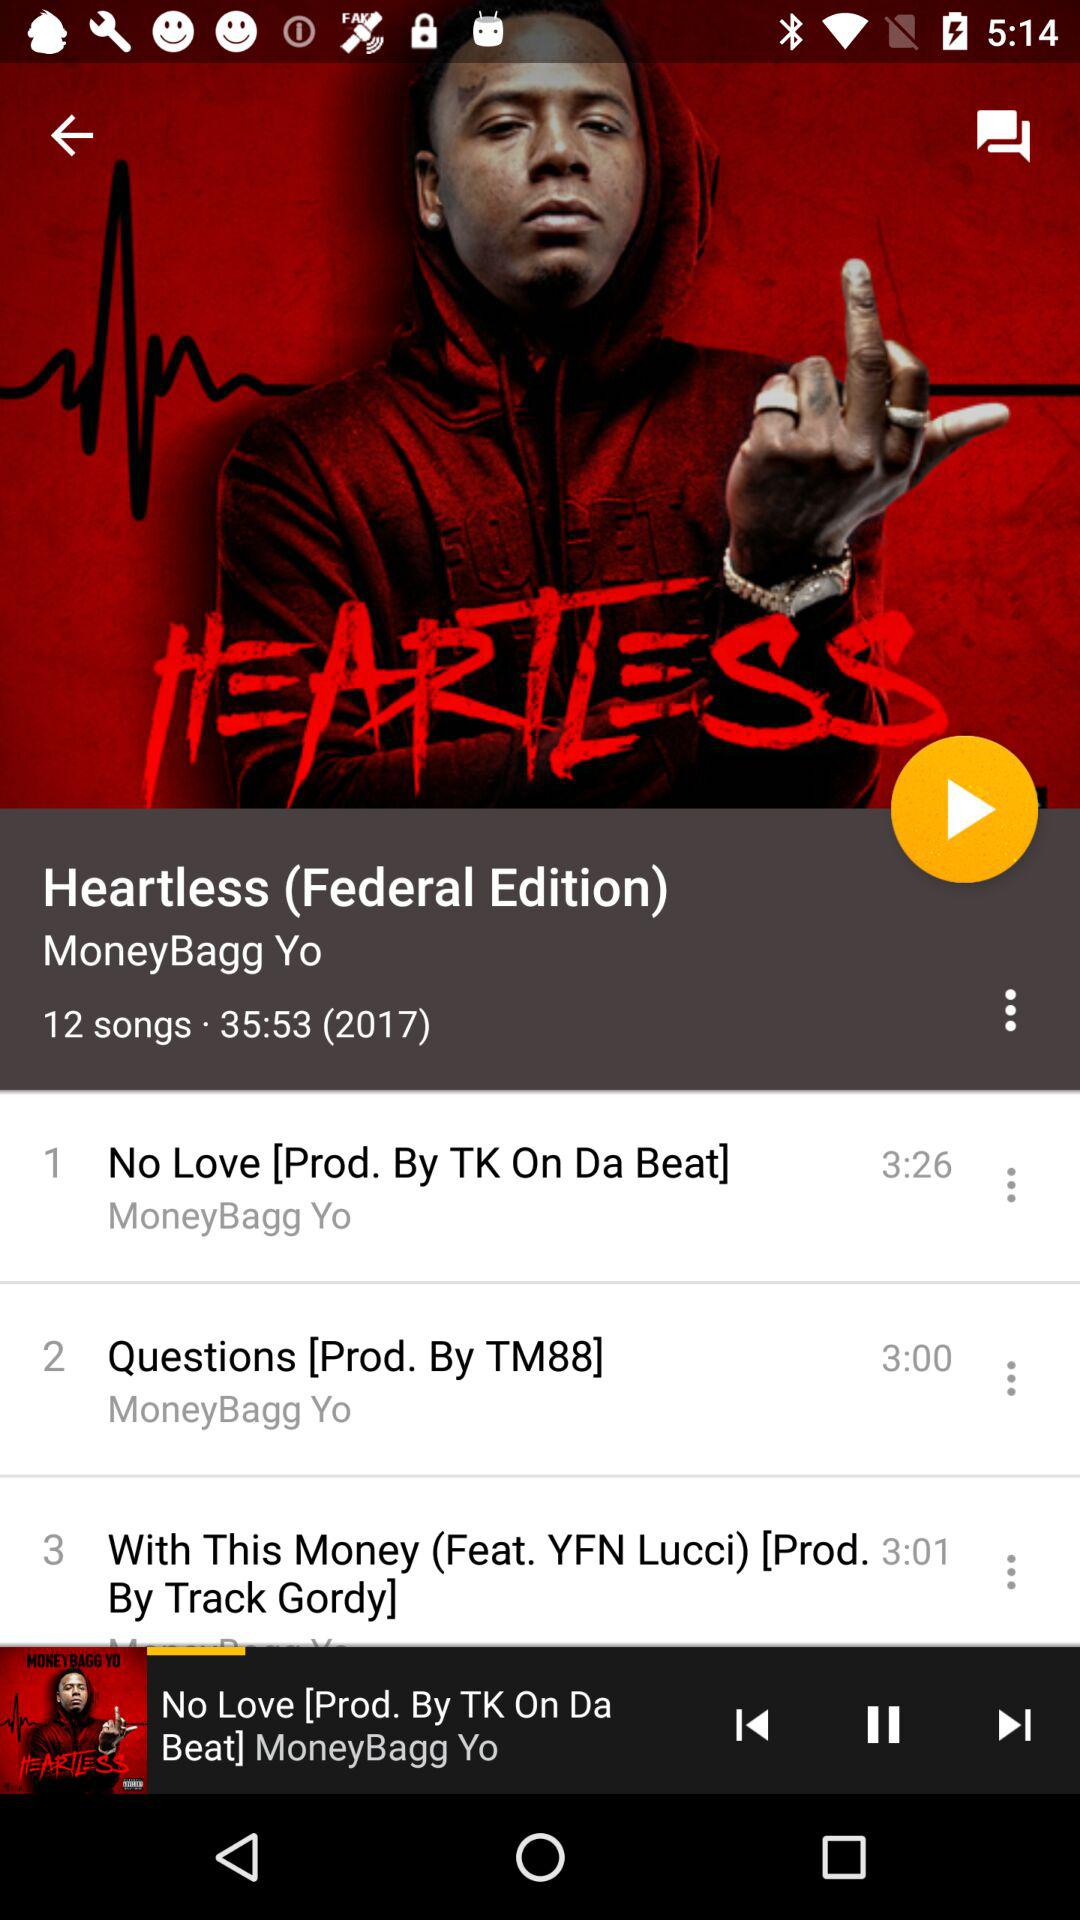What is the name of the producer of the song "No Love"? The name of the producer is TK On Da Beat. 